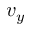Convert formula to latex. <formula><loc_0><loc_0><loc_500><loc_500>v _ { y }</formula> 